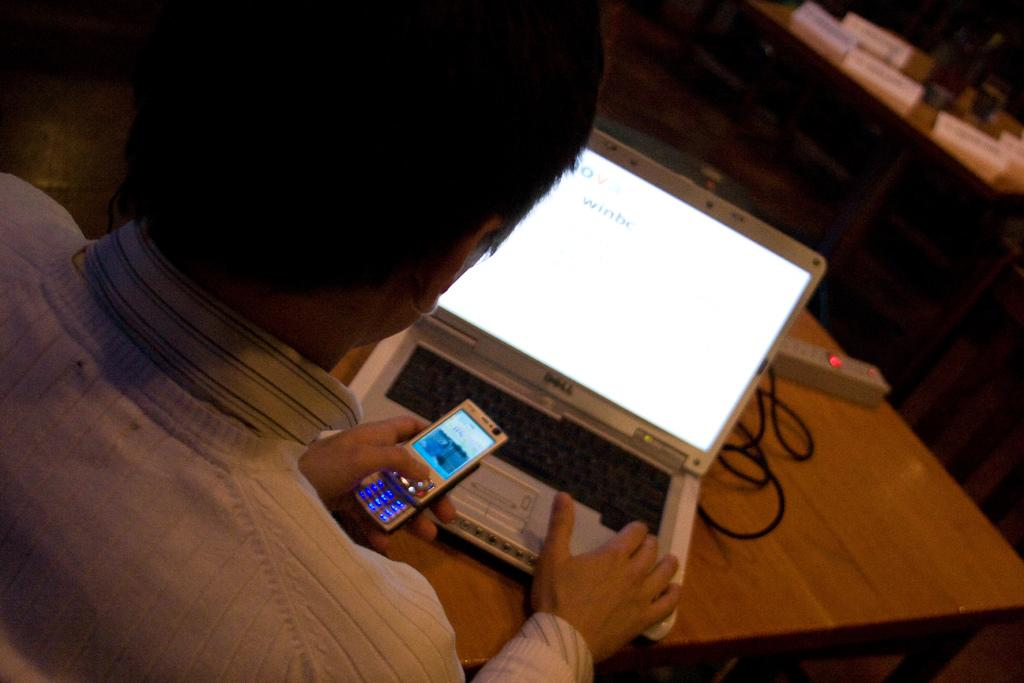<image>
Create a compact narrative representing the image presented. A man holding a cellphone is using a Dell laptop. 